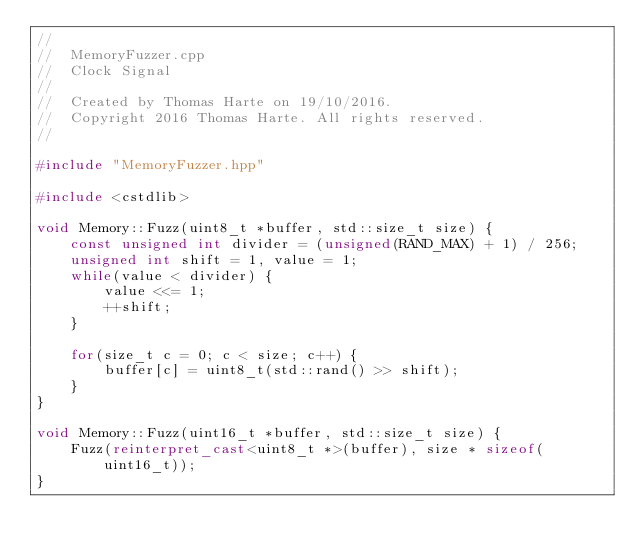Convert code to text. <code><loc_0><loc_0><loc_500><loc_500><_C++_>//
//  MemoryFuzzer.cpp
//  Clock Signal
//
//  Created by Thomas Harte on 19/10/2016.
//  Copyright 2016 Thomas Harte. All rights reserved.
//

#include "MemoryFuzzer.hpp"

#include <cstdlib>

void Memory::Fuzz(uint8_t *buffer, std::size_t size) {
	const unsigned int divider = (unsigned(RAND_MAX) + 1) / 256;
	unsigned int shift = 1, value = 1;
	while(value < divider) {
		value <<= 1;
		++shift;
	}

	for(size_t c = 0; c < size; c++) {
		buffer[c] = uint8_t(std::rand() >> shift);
	}
}

void Memory::Fuzz(uint16_t *buffer, std::size_t size) {
	Fuzz(reinterpret_cast<uint8_t *>(buffer), size * sizeof(uint16_t));
}
</code> 